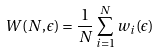<formula> <loc_0><loc_0><loc_500><loc_500>W ( N , \epsilon ) = \frac { 1 } { N } \sum _ { i = 1 } ^ { N } w _ { i } ( \epsilon )</formula> 